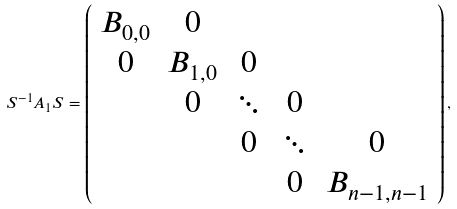<formula> <loc_0><loc_0><loc_500><loc_500>S ^ { - 1 } A _ { 1 } S = \left ( \begin{array} { c c c c c } B _ { 0 , 0 } & 0 & & & \\ 0 & B _ { 1 , 0 } & 0 & & \\ & 0 & \ddots & 0 & \\ & & 0 & \ddots & 0 \\ & & & 0 & B _ { n - 1 , n - 1 } \end{array} \right ) ,</formula> 